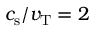Convert formula to latex. <formula><loc_0><loc_0><loc_500><loc_500>c _ { s } / v _ { T } = 2</formula> 